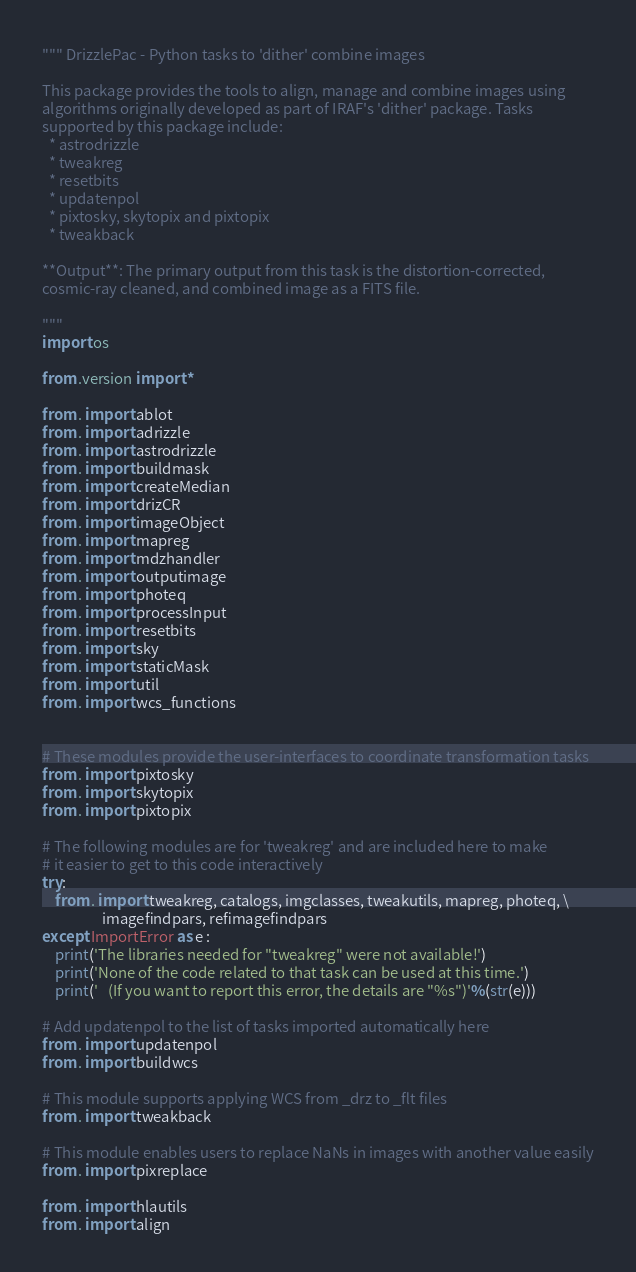<code> <loc_0><loc_0><loc_500><loc_500><_Python_>""" DrizzlePac - Python tasks to 'dither' combine images

This package provides the tools to align, manage and combine images using
algorithms originally developed as part of IRAF's 'dither' package. Tasks
supported by this package include:
  * astrodrizzle
  * tweakreg
  * resetbits
  * updatenpol
  * pixtosky, skytopix and pixtopix
  * tweakback

**Output**: The primary output from this task is the distortion-corrected,
cosmic-ray cleaned, and combined image as a FITS file.

"""
import os

from .version import *

from . import ablot
from . import adrizzle
from . import astrodrizzle
from . import buildmask
from . import createMedian
from . import drizCR
from . import imageObject
from . import mapreg
from . import mdzhandler
from . import outputimage
from . import photeq
from . import processInput
from . import resetbits
from . import sky
from . import staticMask
from . import util
from . import wcs_functions


# These modules provide the user-interfaces to coordinate transformation tasks
from . import pixtosky
from . import skytopix
from . import pixtopix

# The following modules are for 'tweakreg' and are included here to make
# it easier to get to this code interactively
try:
    from . import tweakreg, catalogs, imgclasses, tweakutils, mapreg, photeq, \
                  imagefindpars, refimagefindpars
except ImportError as e :
    print('The libraries needed for "tweakreg" were not available!')
    print('None of the code related to that task can be used at this time.')
    print('   (If you want to report this error, the details are "%s")'%(str(e)))

# Add updatenpol to the list of tasks imported automatically here
from . import updatenpol
from . import buildwcs

# This module supports applying WCS from _drz to _flt files
from . import tweakback

# This module enables users to replace NaNs in images with another value easily
from . import pixreplace

from . import hlautils
from . import align</code> 